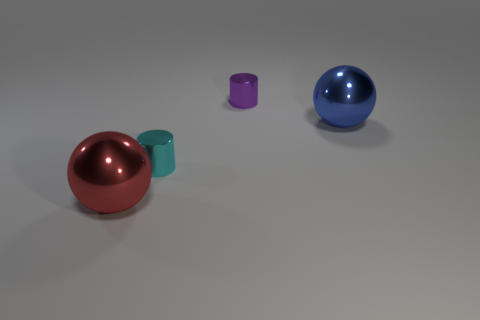The big object that is on the left side of the blue sphere is what color?
Offer a terse response. Red. What is the shape of the large blue metal thing?
Your answer should be very brief. Sphere. There is a big sphere that is in front of the big shiny object right of the red metallic object; what is it made of?
Provide a short and direct response. Metal. How many other objects are the same material as the large red thing?
Offer a terse response. 3. There is a red object that is the same size as the blue object; what is its material?
Provide a succinct answer. Metal. Is the number of small shiny cylinders that are right of the cyan cylinder greater than the number of metallic spheres that are behind the blue sphere?
Give a very brief answer. Yes. Are there any tiny red matte things of the same shape as the small purple shiny object?
Ensure brevity in your answer.  No. There is a purple metallic thing that is the same size as the cyan thing; what shape is it?
Give a very brief answer. Cylinder. There is a big shiny object behind the red thing; what is its shape?
Make the answer very short. Sphere. Is the number of small cyan metal cylinders in front of the big red metallic object less than the number of small cyan shiny cylinders that are behind the purple shiny cylinder?
Ensure brevity in your answer.  No. 